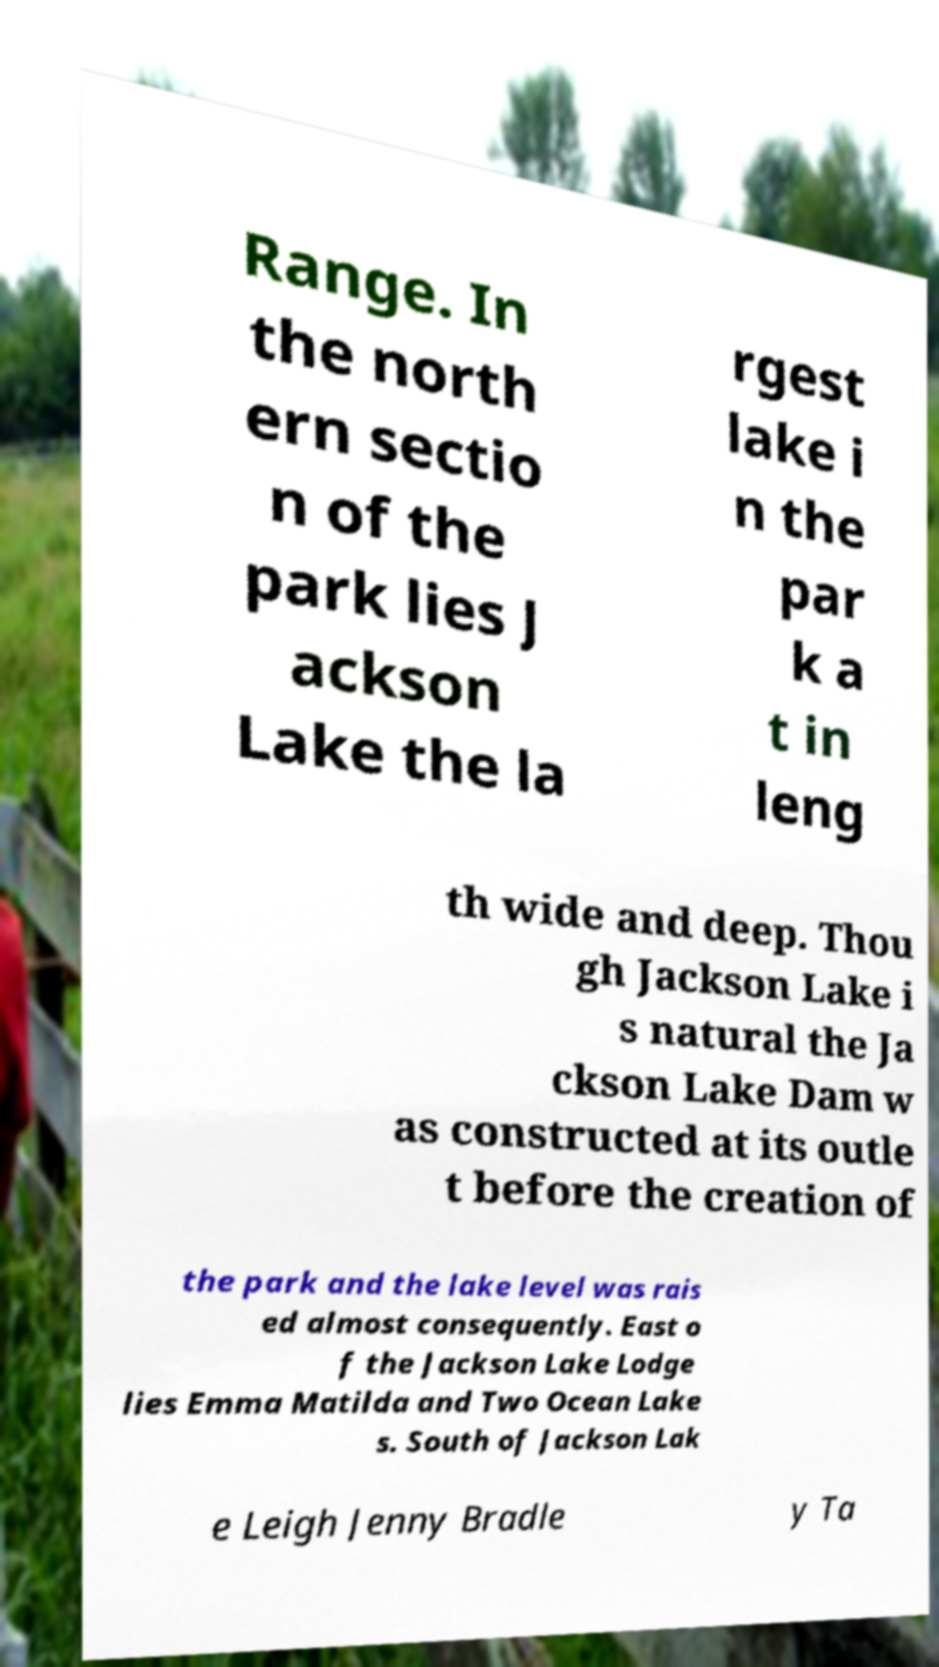Could you assist in decoding the text presented in this image and type it out clearly? Range. In the north ern sectio n of the park lies J ackson Lake the la rgest lake i n the par k a t in leng th wide and deep. Thou gh Jackson Lake i s natural the Ja ckson Lake Dam w as constructed at its outle t before the creation of the park and the lake level was rais ed almost consequently. East o f the Jackson Lake Lodge lies Emma Matilda and Two Ocean Lake s. South of Jackson Lak e Leigh Jenny Bradle y Ta 